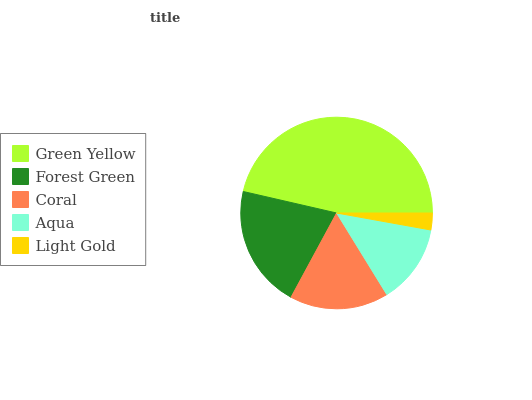Is Light Gold the minimum?
Answer yes or no. Yes. Is Green Yellow the maximum?
Answer yes or no. Yes. Is Forest Green the minimum?
Answer yes or no. No. Is Forest Green the maximum?
Answer yes or no. No. Is Green Yellow greater than Forest Green?
Answer yes or no. Yes. Is Forest Green less than Green Yellow?
Answer yes or no. Yes. Is Forest Green greater than Green Yellow?
Answer yes or no. No. Is Green Yellow less than Forest Green?
Answer yes or no. No. Is Coral the high median?
Answer yes or no. Yes. Is Coral the low median?
Answer yes or no. Yes. Is Aqua the high median?
Answer yes or no. No. Is Aqua the low median?
Answer yes or no. No. 